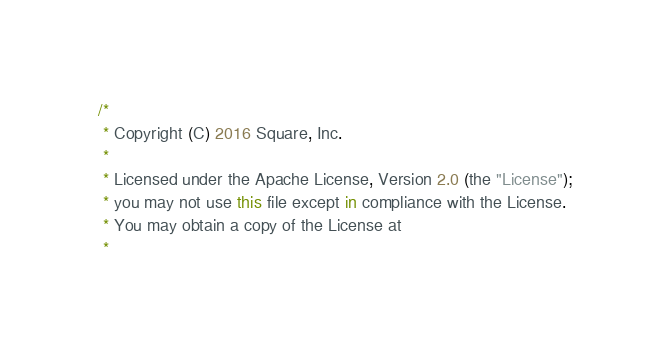Convert code to text. <code><loc_0><loc_0><loc_500><loc_500><_Kotlin_>/*
 * Copyright (C) 2016 Square, Inc.
 *
 * Licensed under the Apache License, Version 2.0 (the "License");
 * you may not use this file except in compliance with the License.
 * You may obtain a copy of the License at
 *</code> 